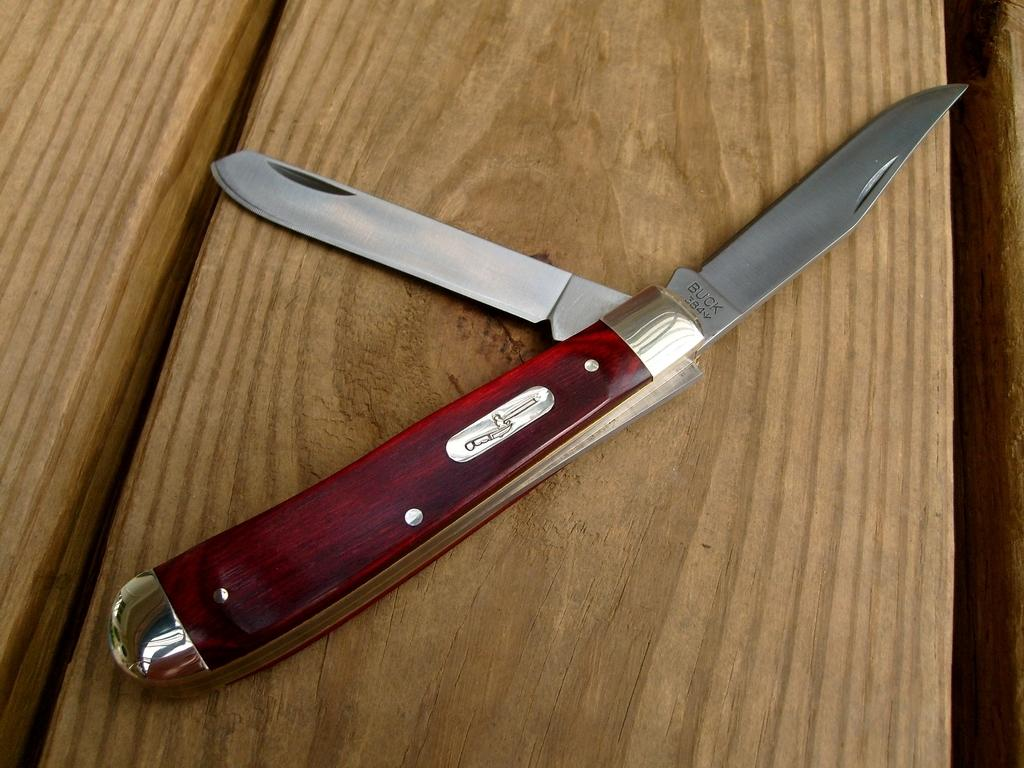What object can be seen in the image? There is a knife in the image. What type of offer is being made with the knife in the image? There is no offer being made with the knife in the image; it is simply an object present in the scene. 